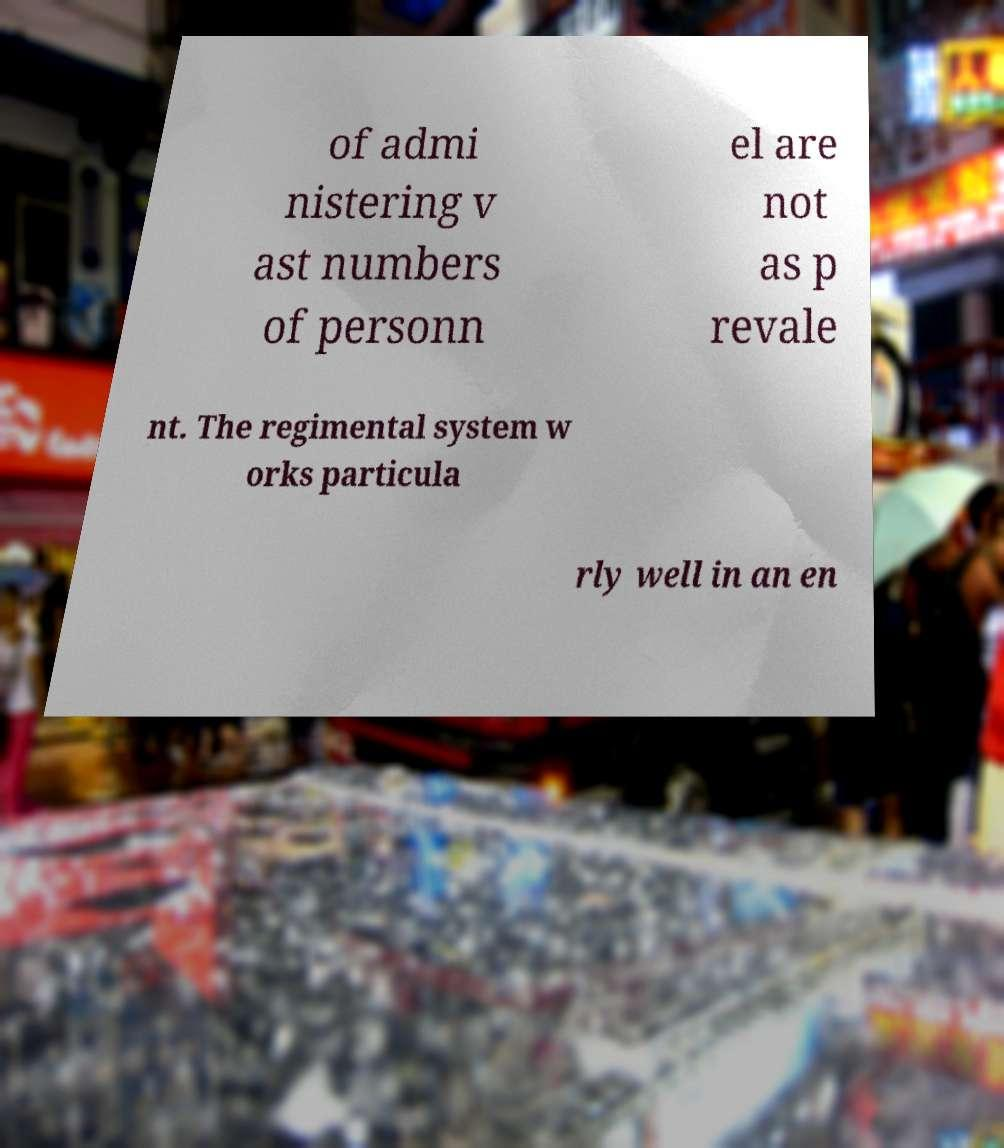Please read and relay the text visible in this image. What does it say? of admi nistering v ast numbers of personn el are not as p revale nt. The regimental system w orks particula rly well in an en 